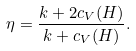Convert formula to latex. <formula><loc_0><loc_0><loc_500><loc_500>\eta = \frac { k + 2 c _ { V } ( H ) } { k + c _ { V } ( H ) } .</formula> 